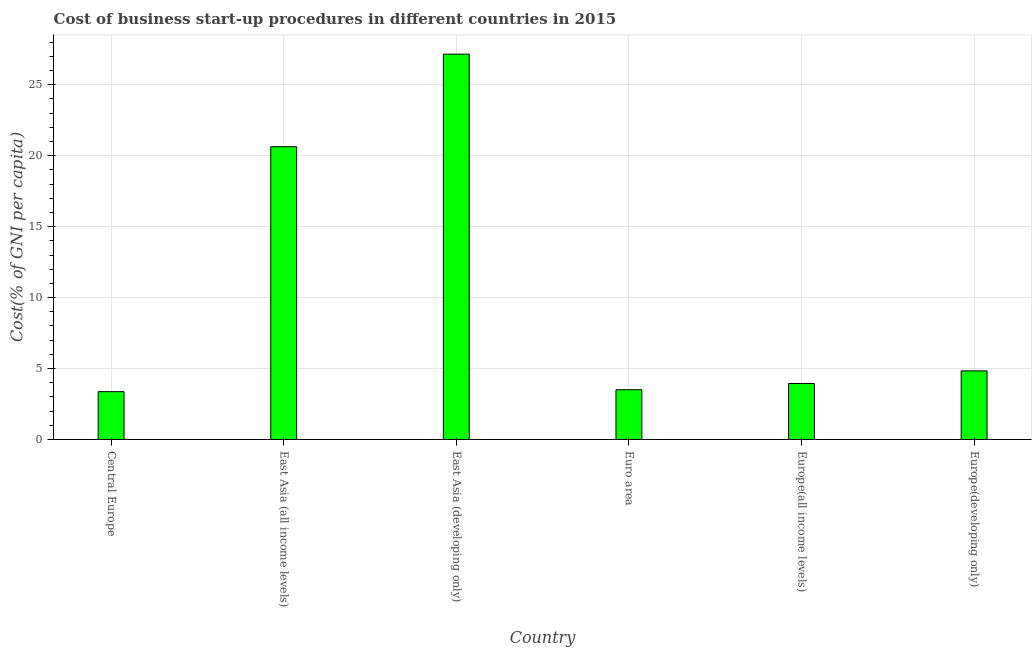Does the graph contain grids?
Your response must be concise. Yes. What is the title of the graph?
Keep it short and to the point. Cost of business start-up procedures in different countries in 2015. What is the label or title of the X-axis?
Your answer should be compact. Country. What is the label or title of the Y-axis?
Give a very brief answer. Cost(% of GNI per capita). What is the cost of business startup procedures in Central Europe?
Your answer should be compact. 3.37. Across all countries, what is the maximum cost of business startup procedures?
Make the answer very short. 27.16. Across all countries, what is the minimum cost of business startup procedures?
Offer a terse response. 3.37. In which country was the cost of business startup procedures maximum?
Your answer should be compact. East Asia (developing only). In which country was the cost of business startup procedures minimum?
Offer a terse response. Central Europe. What is the sum of the cost of business startup procedures?
Ensure brevity in your answer.  63.46. What is the difference between the cost of business startup procedures in Central Europe and Euro area?
Your answer should be compact. -0.14. What is the average cost of business startup procedures per country?
Provide a succinct answer. 10.58. What is the median cost of business startup procedures?
Offer a very short reply. 4.39. What is the ratio of the cost of business startup procedures in East Asia (developing only) to that in Europe(developing only)?
Provide a short and direct response. 5.62. Is the difference between the cost of business startup procedures in East Asia (developing only) and Europe(developing only) greater than the difference between any two countries?
Provide a short and direct response. No. What is the difference between the highest and the second highest cost of business startup procedures?
Give a very brief answer. 6.52. Is the sum of the cost of business startup procedures in East Asia (developing only) and Europe(all income levels) greater than the maximum cost of business startup procedures across all countries?
Your answer should be compact. Yes. What is the difference between the highest and the lowest cost of business startup procedures?
Keep it short and to the point. 23.78. In how many countries, is the cost of business startup procedures greater than the average cost of business startup procedures taken over all countries?
Your answer should be compact. 2. How many bars are there?
Give a very brief answer. 6. How many countries are there in the graph?
Your response must be concise. 6. What is the difference between two consecutive major ticks on the Y-axis?
Ensure brevity in your answer.  5. What is the Cost(% of GNI per capita) of Central Europe?
Provide a succinct answer. 3.37. What is the Cost(% of GNI per capita) of East Asia (all income levels)?
Keep it short and to the point. 20.63. What is the Cost(% of GNI per capita) in East Asia (developing only)?
Keep it short and to the point. 27.16. What is the Cost(% of GNI per capita) of Euro area?
Provide a short and direct response. 3.51. What is the Cost(% of GNI per capita) of Europe(all income levels)?
Make the answer very short. 3.95. What is the Cost(% of GNI per capita) of Europe(developing only)?
Keep it short and to the point. 4.84. What is the difference between the Cost(% of GNI per capita) in Central Europe and East Asia (all income levels)?
Offer a terse response. -17.26. What is the difference between the Cost(% of GNI per capita) in Central Europe and East Asia (developing only)?
Keep it short and to the point. -23.78. What is the difference between the Cost(% of GNI per capita) in Central Europe and Euro area?
Make the answer very short. -0.14. What is the difference between the Cost(% of GNI per capita) in Central Europe and Europe(all income levels)?
Offer a very short reply. -0.58. What is the difference between the Cost(% of GNI per capita) in Central Europe and Europe(developing only)?
Provide a short and direct response. -1.46. What is the difference between the Cost(% of GNI per capita) in East Asia (all income levels) and East Asia (developing only)?
Your answer should be compact. -6.52. What is the difference between the Cost(% of GNI per capita) in East Asia (all income levels) and Euro area?
Offer a very short reply. 17.12. What is the difference between the Cost(% of GNI per capita) in East Asia (all income levels) and Europe(all income levels)?
Keep it short and to the point. 16.69. What is the difference between the Cost(% of GNI per capita) in East Asia (all income levels) and Europe(developing only)?
Your answer should be compact. 15.8. What is the difference between the Cost(% of GNI per capita) in East Asia (developing only) and Euro area?
Provide a short and direct response. 23.65. What is the difference between the Cost(% of GNI per capita) in East Asia (developing only) and Europe(all income levels)?
Ensure brevity in your answer.  23.21. What is the difference between the Cost(% of GNI per capita) in East Asia (developing only) and Europe(developing only)?
Provide a succinct answer. 22.32. What is the difference between the Cost(% of GNI per capita) in Euro area and Europe(all income levels)?
Provide a short and direct response. -0.44. What is the difference between the Cost(% of GNI per capita) in Euro area and Europe(developing only)?
Keep it short and to the point. -1.33. What is the difference between the Cost(% of GNI per capita) in Europe(all income levels) and Europe(developing only)?
Make the answer very short. -0.89. What is the ratio of the Cost(% of GNI per capita) in Central Europe to that in East Asia (all income levels)?
Your answer should be compact. 0.16. What is the ratio of the Cost(% of GNI per capita) in Central Europe to that in East Asia (developing only)?
Ensure brevity in your answer.  0.12. What is the ratio of the Cost(% of GNI per capita) in Central Europe to that in Europe(all income levels)?
Keep it short and to the point. 0.85. What is the ratio of the Cost(% of GNI per capita) in Central Europe to that in Europe(developing only)?
Give a very brief answer. 0.7. What is the ratio of the Cost(% of GNI per capita) in East Asia (all income levels) to that in East Asia (developing only)?
Keep it short and to the point. 0.76. What is the ratio of the Cost(% of GNI per capita) in East Asia (all income levels) to that in Euro area?
Your answer should be very brief. 5.88. What is the ratio of the Cost(% of GNI per capita) in East Asia (all income levels) to that in Europe(all income levels)?
Offer a terse response. 5.22. What is the ratio of the Cost(% of GNI per capita) in East Asia (all income levels) to that in Europe(developing only)?
Provide a succinct answer. 4.27. What is the ratio of the Cost(% of GNI per capita) in East Asia (developing only) to that in Euro area?
Offer a very short reply. 7.74. What is the ratio of the Cost(% of GNI per capita) in East Asia (developing only) to that in Europe(all income levels)?
Make the answer very short. 6.88. What is the ratio of the Cost(% of GNI per capita) in East Asia (developing only) to that in Europe(developing only)?
Offer a terse response. 5.62. What is the ratio of the Cost(% of GNI per capita) in Euro area to that in Europe(all income levels)?
Provide a succinct answer. 0.89. What is the ratio of the Cost(% of GNI per capita) in Euro area to that in Europe(developing only)?
Provide a short and direct response. 0.73. What is the ratio of the Cost(% of GNI per capita) in Europe(all income levels) to that in Europe(developing only)?
Provide a succinct answer. 0.82. 